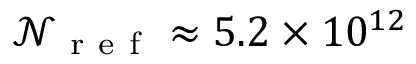<formula> <loc_0><loc_0><loc_500><loc_500>\ m a t h s c r { N } _ { r e f } \approx 5 . 2 \times 1 0 ^ { 1 2 }</formula> 